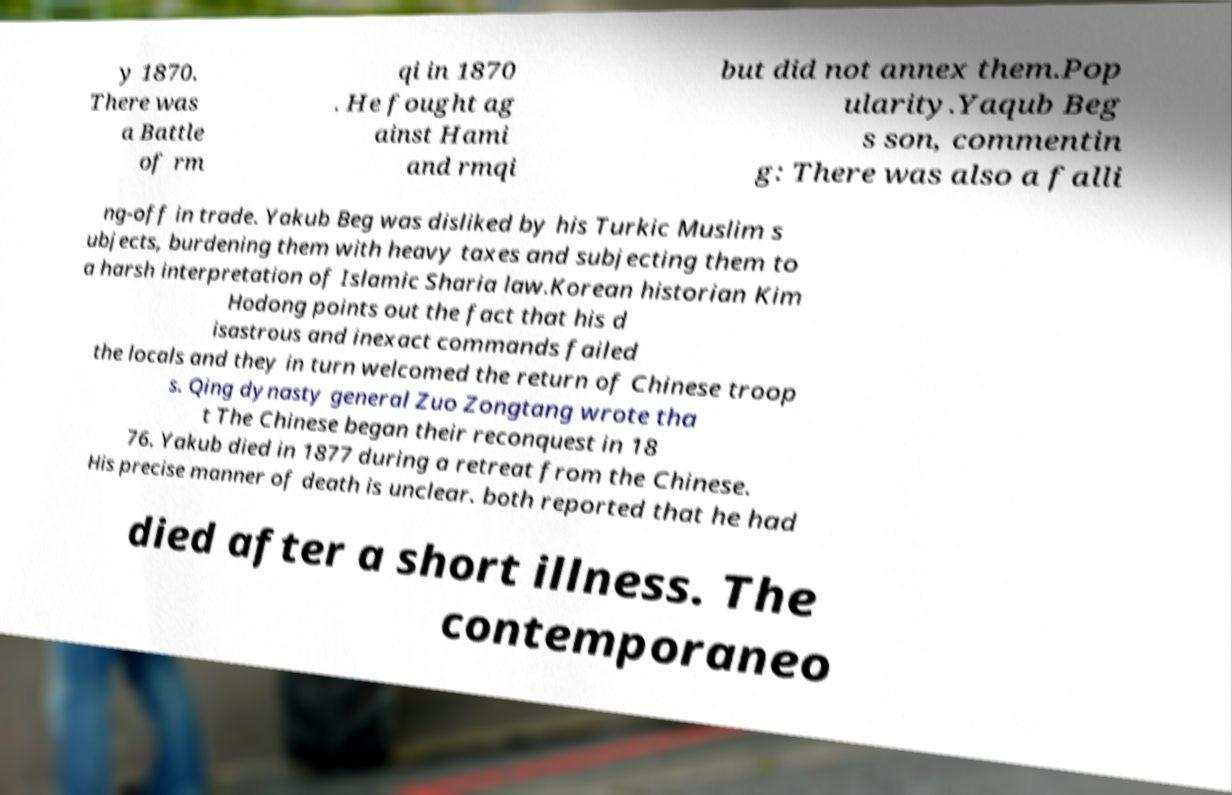Can you accurately transcribe the text from the provided image for me? y 1870. There was a Battle of rm qi in 1870 . He fought ag ainst Hami and rmqi but did not annex them.Pop ularity.Yaqub Beg s son, commentin g: There was also a falli ng-off in trade. Yakub Beg was disliked by his Turkic Muslim s ubjects, burdening them with heavy taxes and subjecting them to a harsh interpretation of Islamic Sharia law.Korean historian Kim Hodong points out the fact that his d isastrous and inexact commands failed the locals and they in turn welcomed the return of Chinese troop s. Qing dynasty general Zuo Zongtang wrote tha t The Chinese began their reconquest in 18 76. Yakub died in 1877 during a retreat from the Chinese. His precise manner of death is unclear. both reported that he had died after a short illness. The contemporaneo 